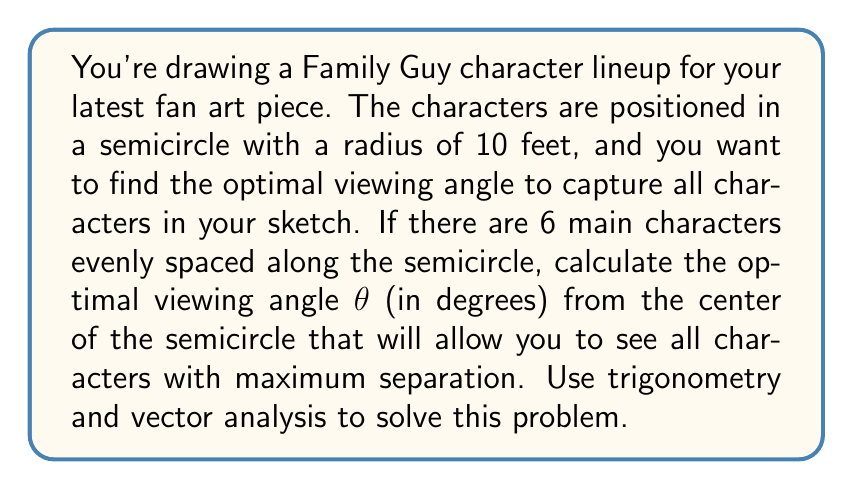Teach me how to tackle this problem. Let's approach this step-by-step:

1) First, we need to understand that the characters are evenly spaced along a semicircle. A semicircle spans 180°, so with 6 characters, the angle between each character from the center is:

   $$\alpha = \frac{180°}{5} = 36°$$

2) We want to find the angle that bisects the arc between the two outermost characters. This will give us the optimal viewing angle. The angle between these two characters is:

   $$5 * 36° = 180°$$

3) To find the optimal viewing angle $\theta$, we need to bisect this angle:

   $$\theta = \frac{180°}{2} = 90°$$

4) We can verify this using vector analysis. Let's consider the vectors to the two outermost characters:

   $$\vec{v_1} = (10\cos(0°), 10\sin(0°)) = (10, 0)$$
   $$\vec{v_2} = (10\cos(180°), 10\sin(180°)) = (-10, 0)$$

5) The optimal viewing vector $\vec{v}$ should be perpendicular to the difference of these vectors:

   $$\vec{v_2} - \vec{v_1} = (-20, 0)$$

6) The perpendicular vector to this is $(0, 1)$, which corresponds to an angle of 90°.

7) We can also confirm this using the dot product. The optimal viewing vector should have equal dot products with $\vec{v_1}$ and $\vec{v_2}$:

   $$\vec{v} \cdot \vec{v_1} = \vec{v} \cdot \vec{v_2}$$

   $$(x, y) \cdot (10, 0) = (x, y) \cdot (-10, 0)$$

   $$10x = -10x$$

   $$x = 0$$

   This means the optimal viewing vector is $(0, y)$, which again corresponds to a 90° angle.

Therefore, the optimal viewing angle is 90° from the center of the semicircle.
Answer: 90° 